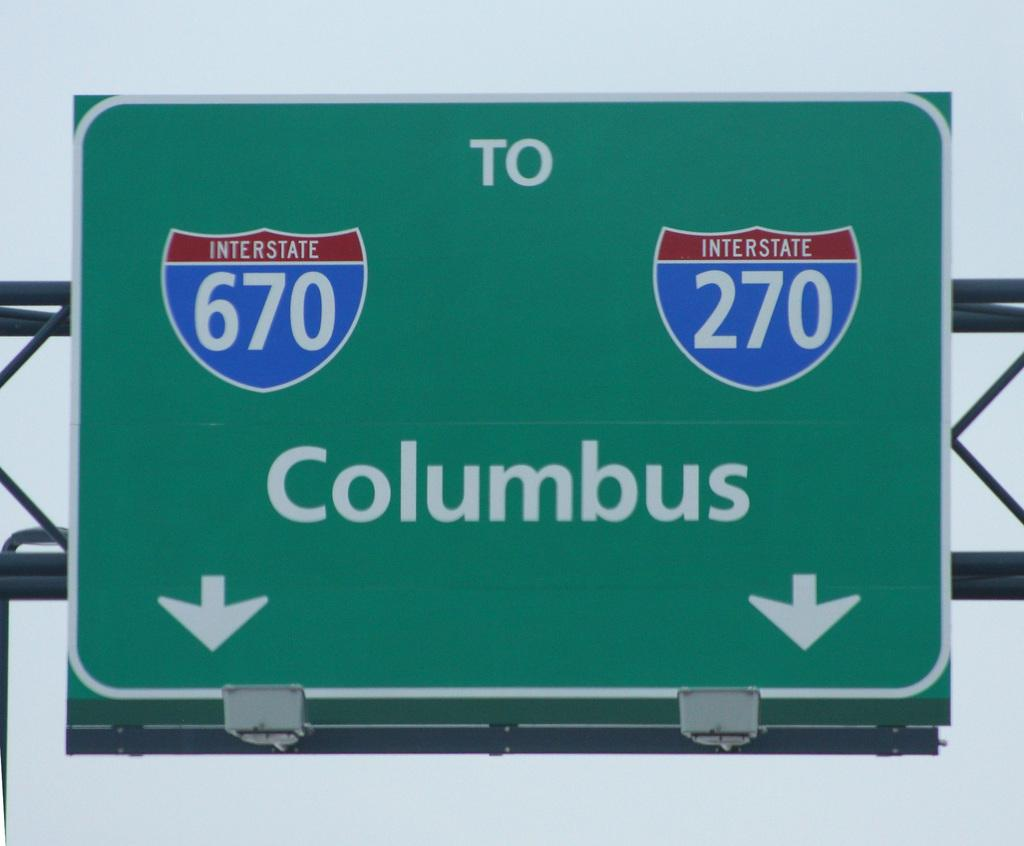<image>
Offer a succinct explanation of the picture presented. A green sign shows that interstates 670 and 270 lead to Columbus. 